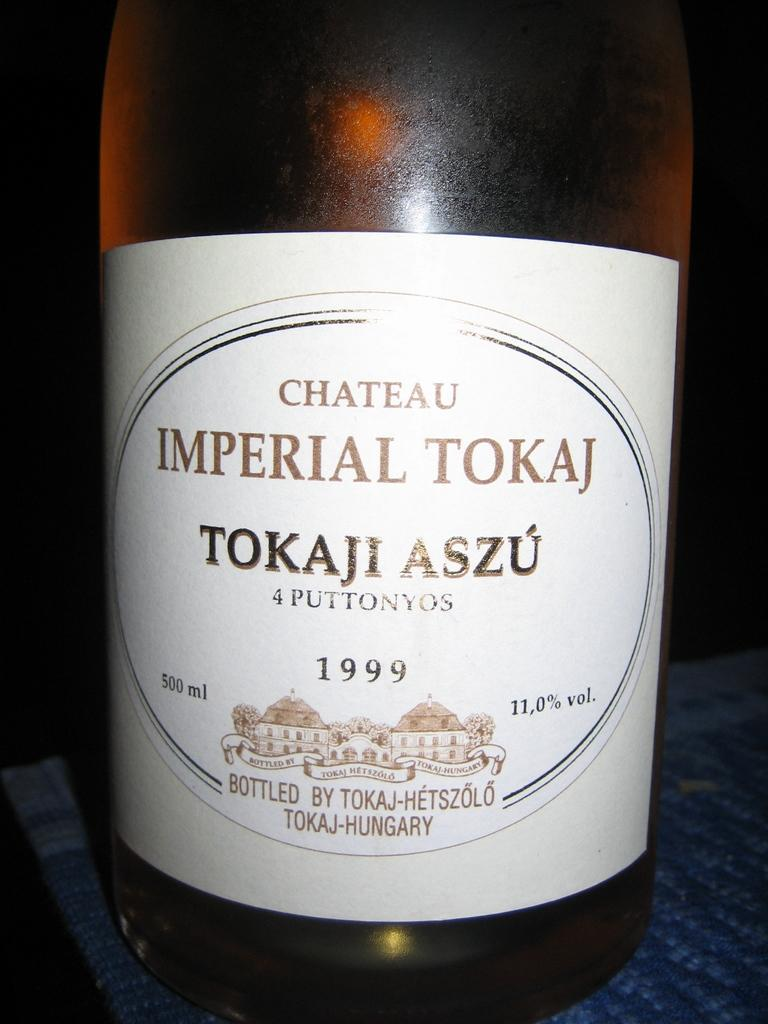<image>
Give a short and clear explanation of the subsequent image. A bottle of wine which has Chateau Imperial Tokaj on the label. 